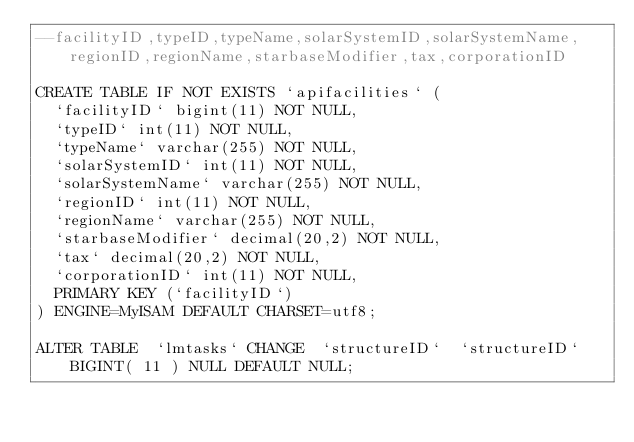Convert code to text. <code><loc_0><loc_0><loc_500><loc_500><_SQL_>--facilityID,typeID,typeName,solarSystemID,solarSystemName,regionID,regionName,starbaseModifier,tax,corporationID

CREATE TABLE IF NOT EXISTS `apifacilities` (
  `facilityID` bigint(11) NOT NULL,
  `typeID` int(11) NOT NULL,
  `typeName` varchar(255) NOT NULL,
  `solarSystemID` int(11) NOT NULL,
  `solarSystemName` varchar(255) NOT NULL,
  `regionID` int(11) NOT NULL,
  `regionName` varchar(255) NOT NULL,
  `starbaseModifier` decimal(20,2) NOT NULL,
  `tax` decimal(20,2) NOT NULL,
  `corporationID` int(11) NOT NULL,
  PRIMARY KEY (`facilityID`)
) ENGINE=MyISAM DEFAULT CHARSET=utf8;	

ALTER TABLE  `lmtasks` CHANGE  `structureID`  `structureID` BIGINT( 11 ) NULL DEFAULT NULL;</code> 